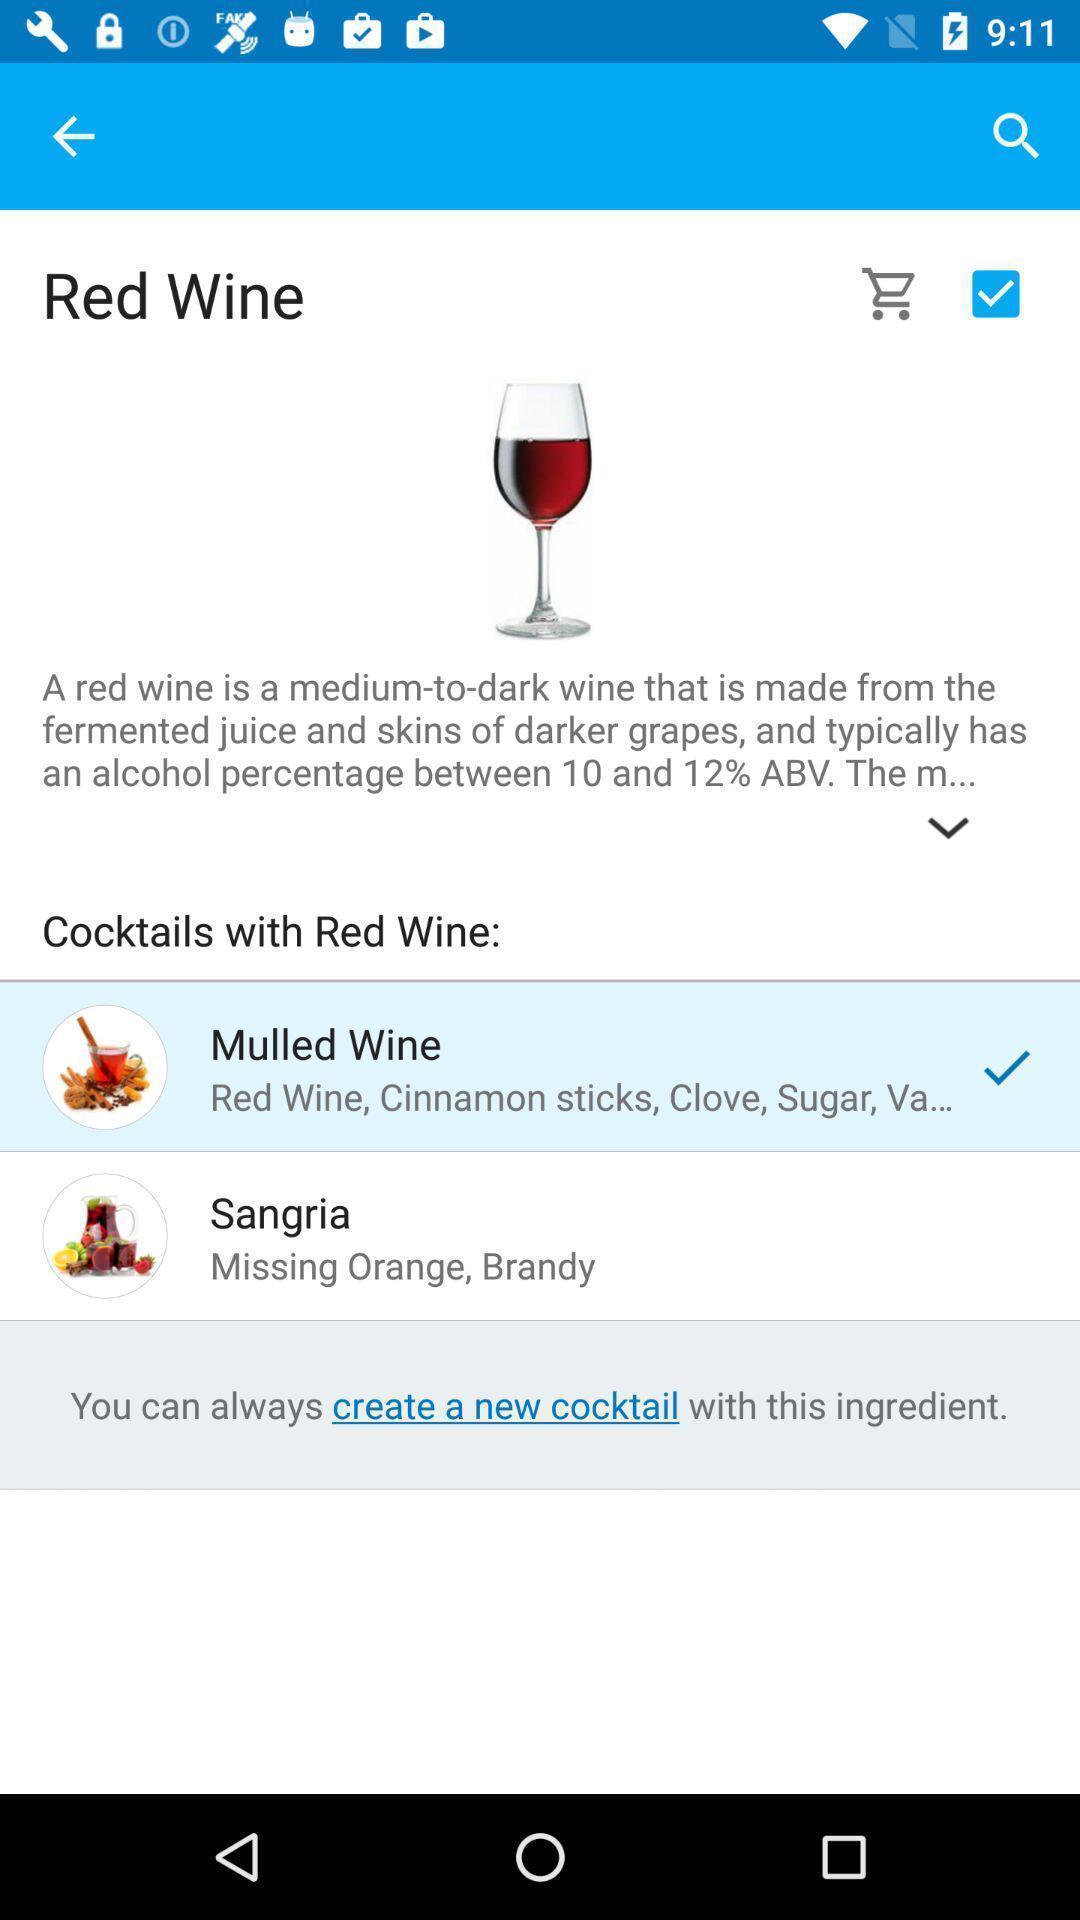Tell me what you see in this picture. Page displaying various alcohols. 